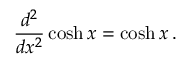<formula> <loc_0><loc_0><loc_500><loc_500>{ \frac { d ^ { 2 } } { d x ^ { 2 } } } \cosh x = \cosh x \, .</formula> 